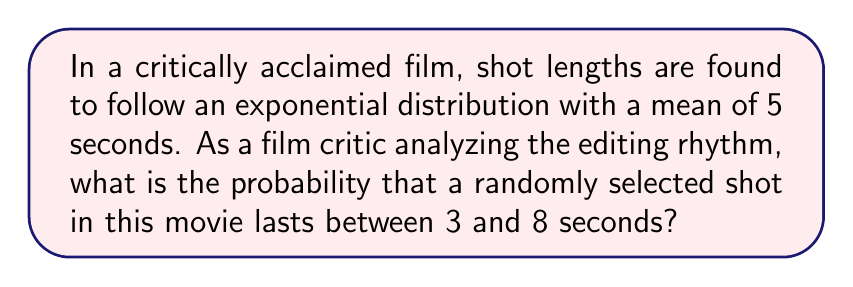Teach me how to tackle this problem. Let's approach this step-by-step:

1) The exponential distribution has the probability density function:
   $$f(x) = \lambda e^{-\lambda x}$$
   where $\lambda$ is the rate parameter.

2) Given that the mean of an exponential distribution is $\frac{1}{\lambda}$, and we're told the mean is 5 seconds, we can determine $\lambda$:
   $$\frac{1}{\lambda} = 5$$
   $$\lambda = \frac{1}{5} = 0.2$$

3) The probability of a shot lasting between 3 and 8 seconds is given by:
   $$P(3 \leq X \leq 8) = \int_3^8 f(x) dx = \int_3^8 0.2e^{-0.2x} dx$$

4) To solve this integral:
   $$\int_3^8 0.2e^{-0.2x} dx = [-e^{-0.2x}]_3^8$$
   $$= -e^{-0.2(8)} - (-e^{-0.2(3)})$$
   $$= -e^{-1.6} + e^{-0.6}$$

5) Calculating these values:
   $$= -(0.2019) + 0.5488 = 0.3469$$

6) Therefore, the probability is approximately 0.3469 or 34.69%.

This analysis reveals that about one-third of the shots in the film fall within this duration range, providing insight into the editing rhythm and pacing of the movie.
Answer: 0.3469 